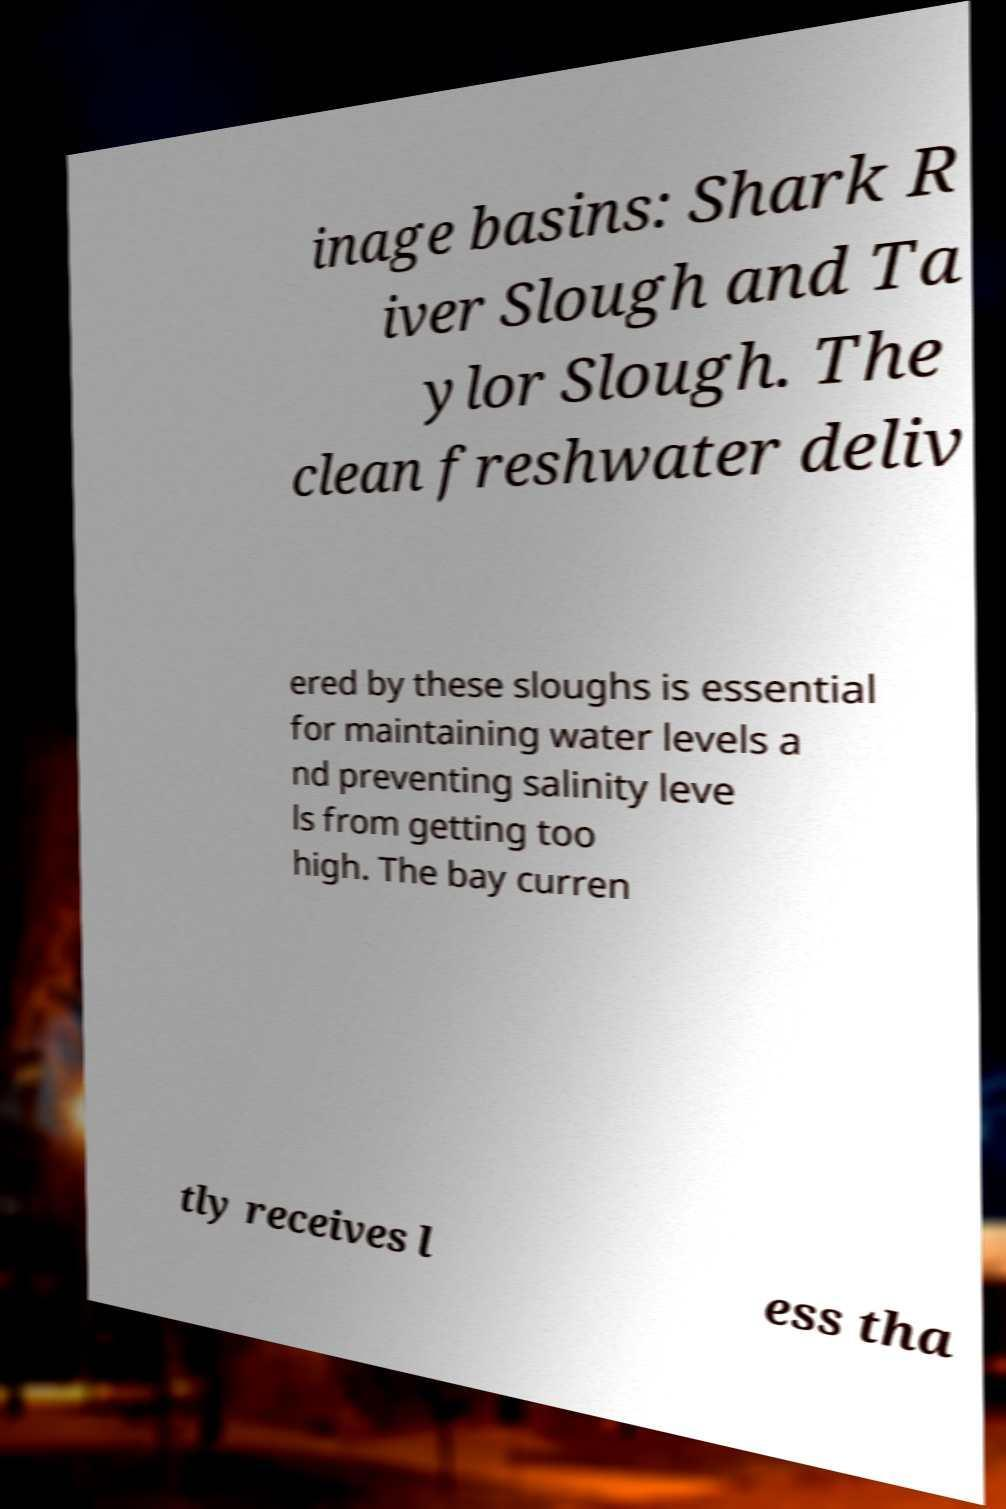For documentation purposes, I need the text within this image transcribed. Could you provide that? inage basins: Shark R iver Slough and Ta ylor Slough. The clean freshwater deliv ered by these sloughs is essential for maintaining water levels a nd preventing salinity leve ls from getting too high. The bay curren tly receives l ess tha 